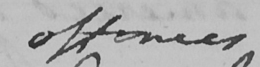Please provide the text content of this handwritten line. offences 